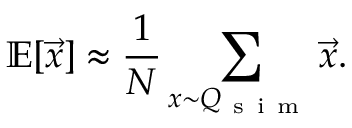Convert formula to latex. <formula><loc_0><loc_0><loc_500><loc_500>\mathbb { E } [ \vec { x } ] \approx \frac { 1 } { N } \sum _ { x { \sim } Q _ { s i m } } \vec { x } .</formula> 